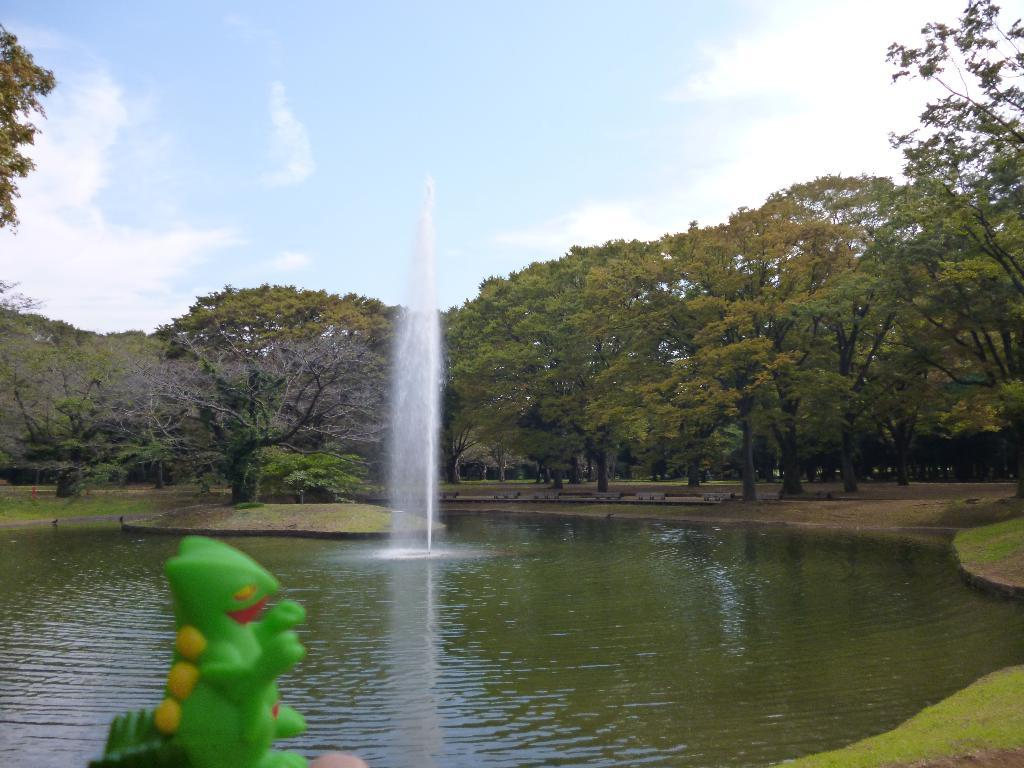What type of water feature is present in the image? There is a canal in the image. What is flowing through the canal? There is water in the canal. Are there any additional features within the water? Yes, there is a fountain in the water. What type of surface surrounds the canal? There is a grass surface around the canal. Are there any plants visible near the canal? Yes, there are trees near the canal. What can be seen in the background of the image? The sky is visible in the background of the image, and clouds are present. What advice does the governor give to the dad in the image? There is no governor or dad present in the image; it features a canal with water, a fountain, grass, trees, and a sky with clouds. 